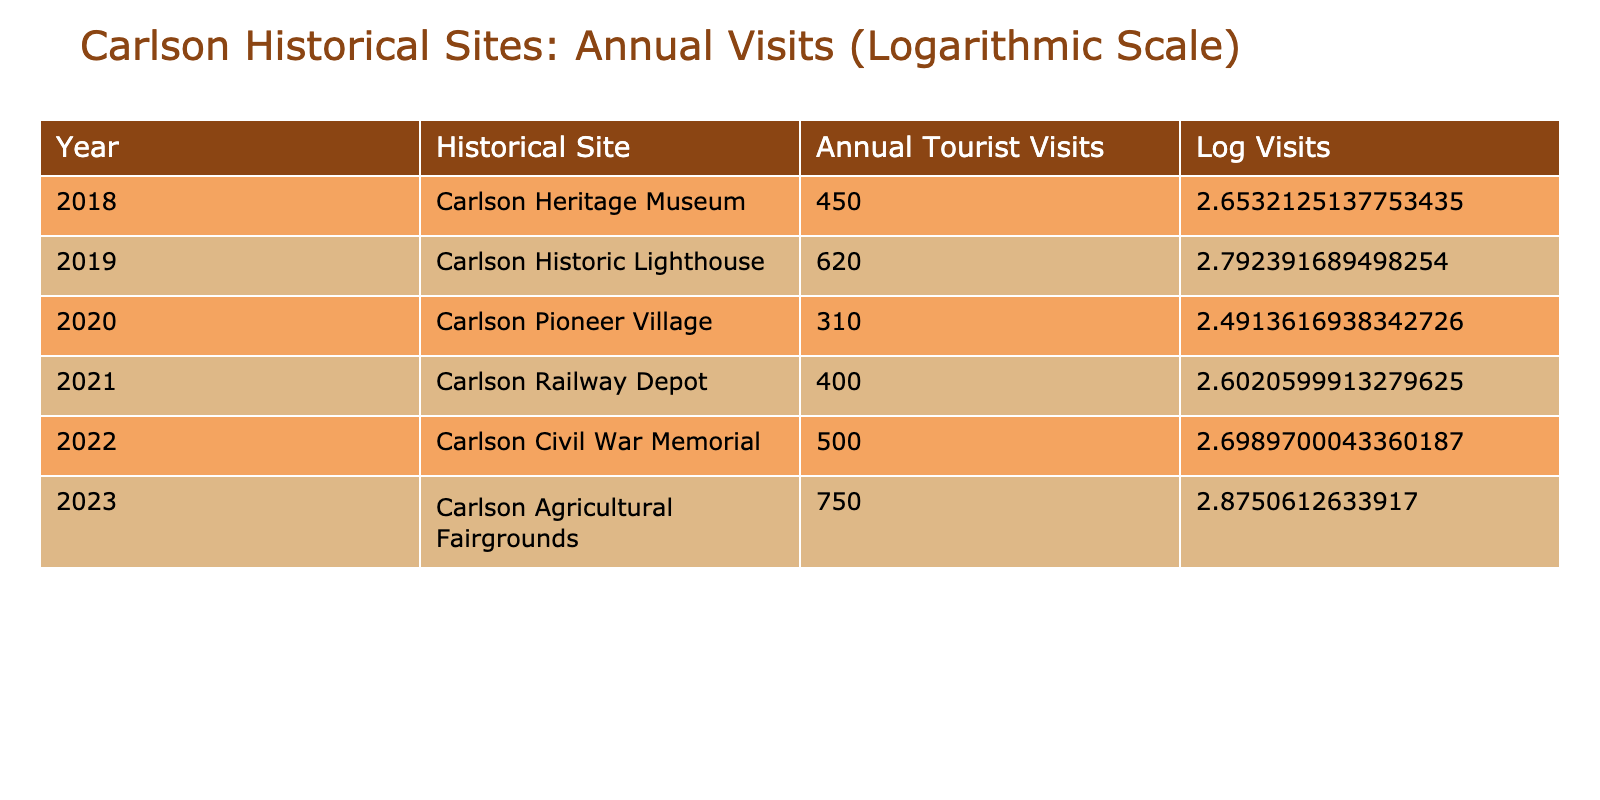What was the annual tourist visit count for the Carlson Heritage Museum in 2018? The table lists the annual tourist visits for each historical site. For the year 2018, it states that the annual tourist visits to Carlson Heritage Museum were 450.
Answer: 450 Which historical site had the highest number of tourist visits in 2023? In 2023, the table shows the annual tourist visits for Carlson Agricultural Fairgrounds, which is 750. By comparing this with other years, it is clear that this is the highest visit count for that year.
Answer: Carlson Agricultural Fairgrounds What is the average number of annual tourist visits across all sites for the year 2022? The annual tourist visits for 2022 are listed as 500, and since we are only looking at this specific year, the average number of visits is simply the same value, 500, because there is only one entry for that year.
Answer: 500 Did the Carlson Railway Depot attract more tourists than the Carlson Pioneer Village in 2020? By looking at the table, the annual tourist visits for Carlson Railway Depot in 2021 (400) and Carlson Pioneer Village in 2020 (310) can be compared. Since 400 is greater than 310, the answer to the question is yes.
Answer: Yes What was the difference in annual visits between the Carlson Historic Lighthouse in 2019 and the Carlson Civil War Memorial in 2022? The number of visits for the Carlson Historic Lighthouse in 2019 was 620 and for the Carlson Civil War Memorial in 2022 it was 500. To find the difference, subtract: 620 - 500 = 120. Thus, the difference in annual visits is 120.
Answer: 120 Which site had fewer tourist visits: Carlson Railway Depot or Carlson Heritage Museum? Carlson Railway Depot for 2021 had 400 visits, while Carlson Heritage Museum for 2018 had 450 visits. When comparing the two values, 400 is less than 450, indicating Carlson Railway Depot had fewer visits.
Answer: Carlson Railway Depot What was the total number of tourist visits to all historical sites from 2018 to 2023? By summing the number of visits (450 + 620 + 310 + 400 + 500 + 750), the total comes to 3030. This involves simple addition of the values in the annual tourist visits column across all listed years.
Answer: 3030 How many historical sites had annual visits greater than 400 in 2023? The only historical site listed for 2023 is Carlson Agricultural Fairgrounds with 750 visits. Since only one site exceeds 400, the answer is one site.
Answer: 1 Is it true that the annual tourist visits decreased from 2019 to 2020? In 2019, the annual visits were 620 for Carlson Historic Lighthouse and in 2020 for Carlson Pioneer Village, it was 310. Since 620 is greater than 310, this statement is true, indicating there was a decrease.
Answer: Yes 